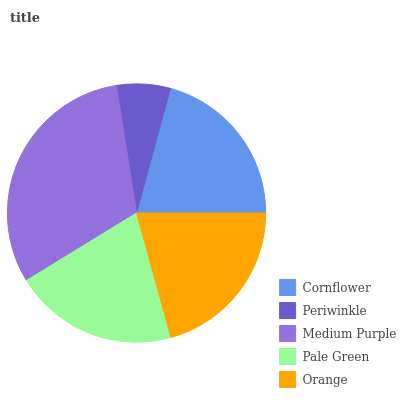Is Periwinkle the minimum?
Answer yes or no. Yes. Is Medium Purple the maximum?
Answer yes or no. Yes. Is Medium Purple the minimum?
Answer yes or no. No. Is Periwinkle the maximum?
Answer yes or no. No. Is Medium Purple greater than Periwinkle?
Answer yes or no. Yes. Is Periwinkle less than Medium Purple?
Answer yes or no. Yes. Is Periwinkle greater than Medium Purple?
Answer yes or no. No. Is Medium Purple less than Periwinkle?
Answer yes or no. No. Is Orange the high median?
Answer yes or no. Yes. Is Orange the low median?
Answer yes or no. Yes. Is Cornflower the high median?
Answer yes or no. No. Is Cornflower the low median?
Answer yes or no. No. 